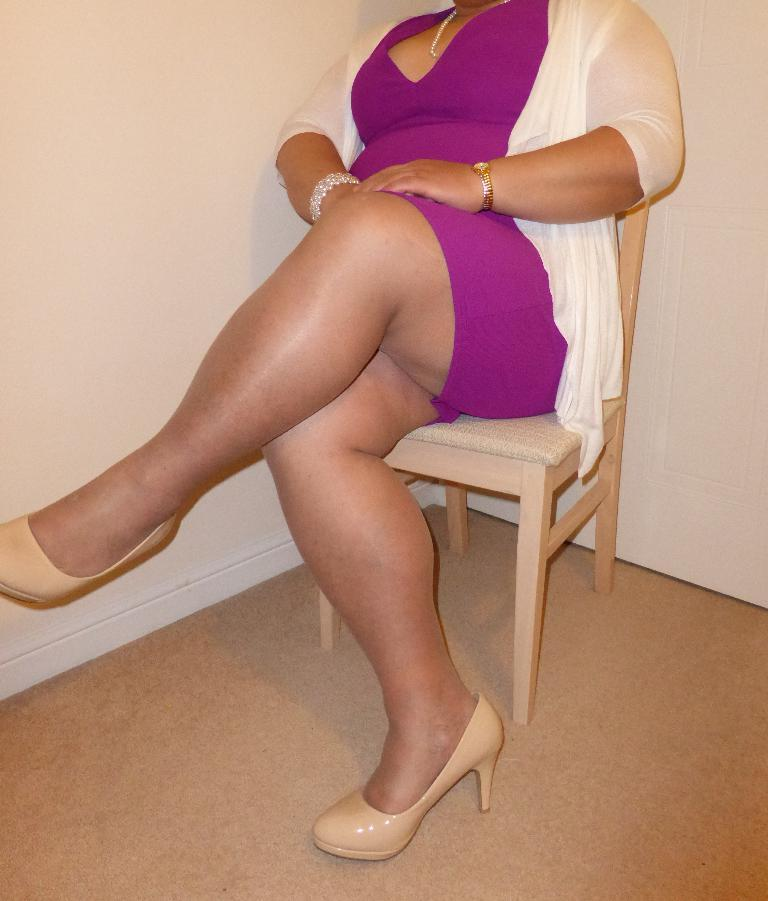Who is present in the image? There is a woman in the image. What is the woman doing in the image? The woman is sitting on a chair. What can be seen in the background of the image? There is a wall in the background of the image. What type of dime is the woman holding in the image? There is no dime present in the image. What event is the woman attending in the image? The image does not provide any information about an event or gathering. 